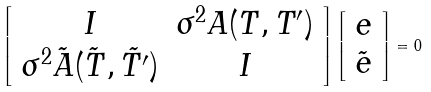<formula> <loc_0><loc_0><loc_500><loc_500>\left [ \begin{array} { c c } { I } & \sigma ^ { 2 } { A } ( { T } , { T ^ { \prime } } ) \\ \sigma ^ { 2 } \tilde { A } ( \tilde { T } , \tilde { T ^ { \prime } } ) & { I } \end{array} \right ] \left [ \begin{array} { c } { e } \\ \tilde { e } \end{array} \right ] = { 0 }</formula> 